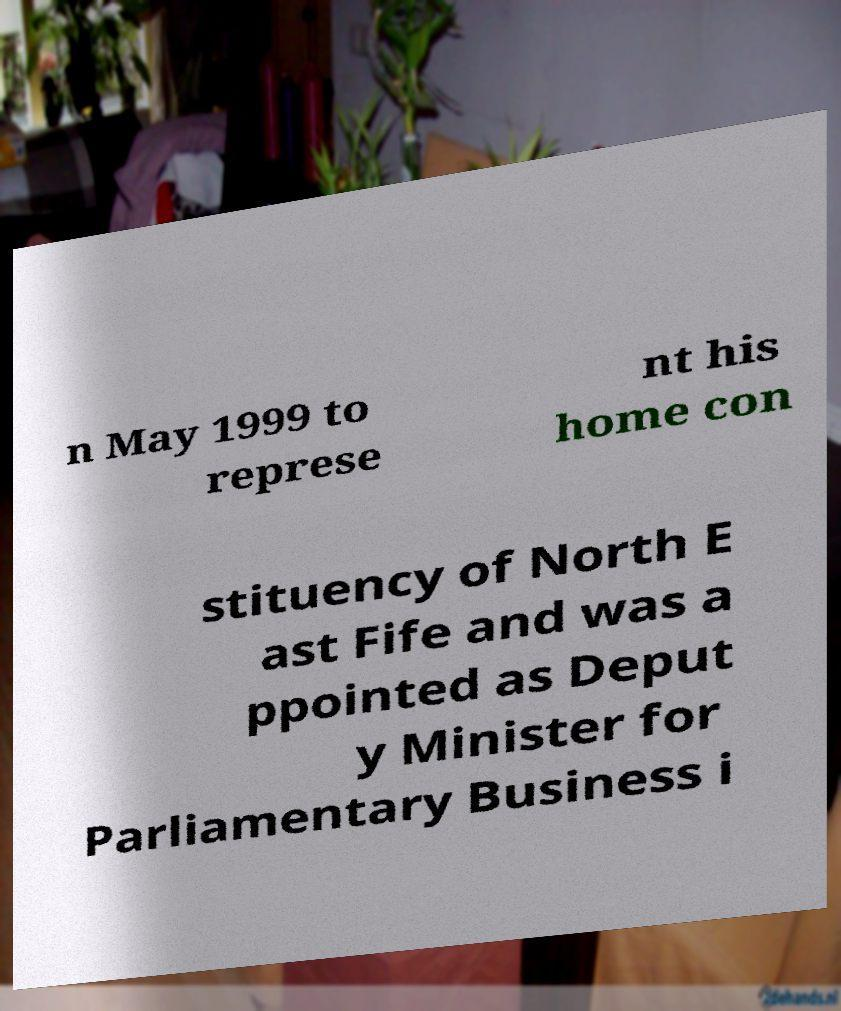There's text embedded in this image that I need extracted. Can you transcribe it verbatim? n May 1999 to represe nt his home con stituency of North E ast Fife and was a ppointed as Deput y Minister for Parliamentary Business i 